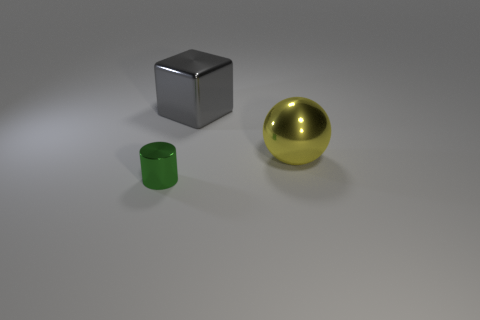What materials do the objects in the image appear to be made of? The objects in the image appear to be rendered with different materials. The cube looks to be made of a polished metal, possibly steel or aluminum, due to its reflective surface. The ball seems to be glossy, indicating it may be a plastic or polished metal sphere. The small cylindrical object has a matte finish, suggesting it could be made of plastic or painted metal. 